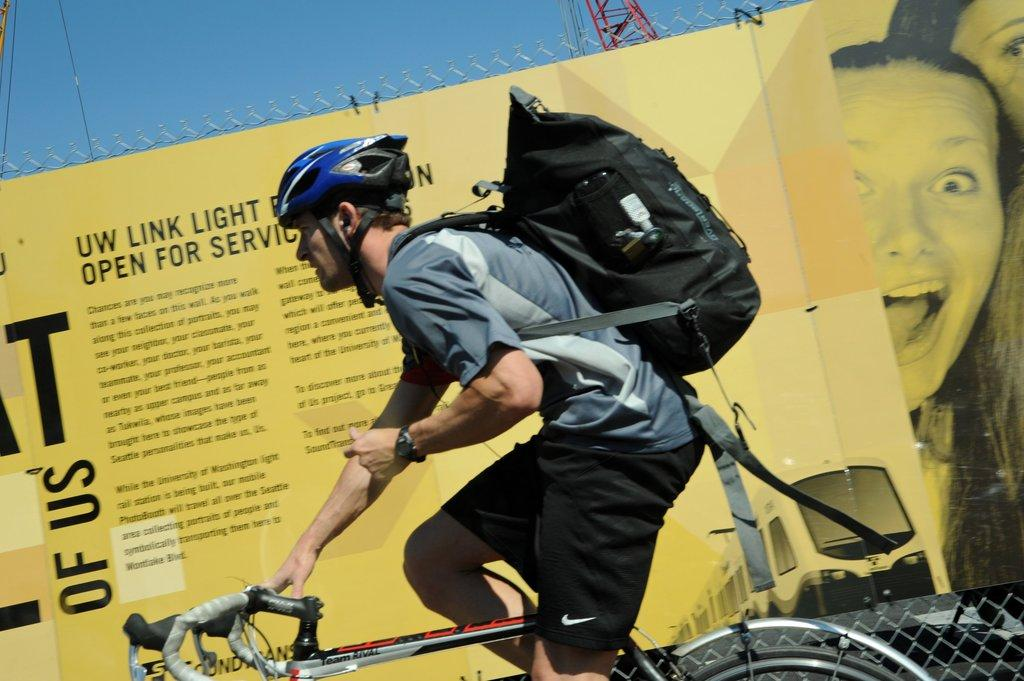What is the main subject of the image? There is a man in the image. What is the man doing in the image? The man is riding a cycle. What is the man carrying while riding the cycle? The man is carrying a backpack. What can be seen in the background of the image? There is a banner and the sky visible in the background of the image. What month is depicted on the banner in the image? There is no month mentioned on the banner in the image. How does the man's credit affect his ability to ride the cycle in the image? There is no information about the man's credit in the image, so we cannot determine its effect on his ability to ride the cycle. 